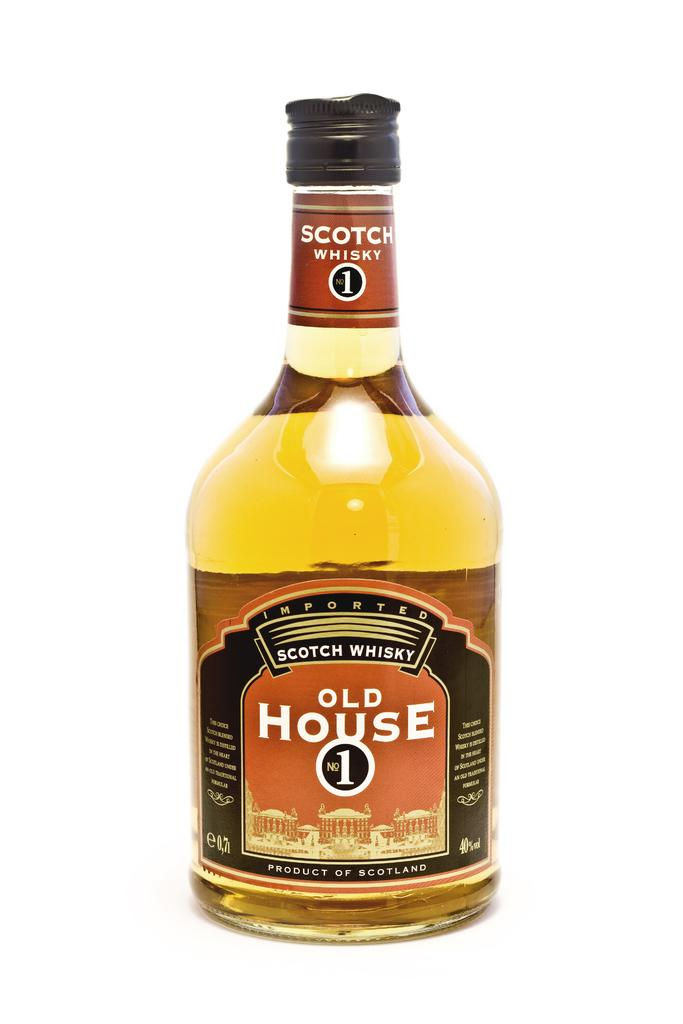<image>
Share a concise interpretation of the image provided. a bottle of scotch whisky that says old house no 1 on it 